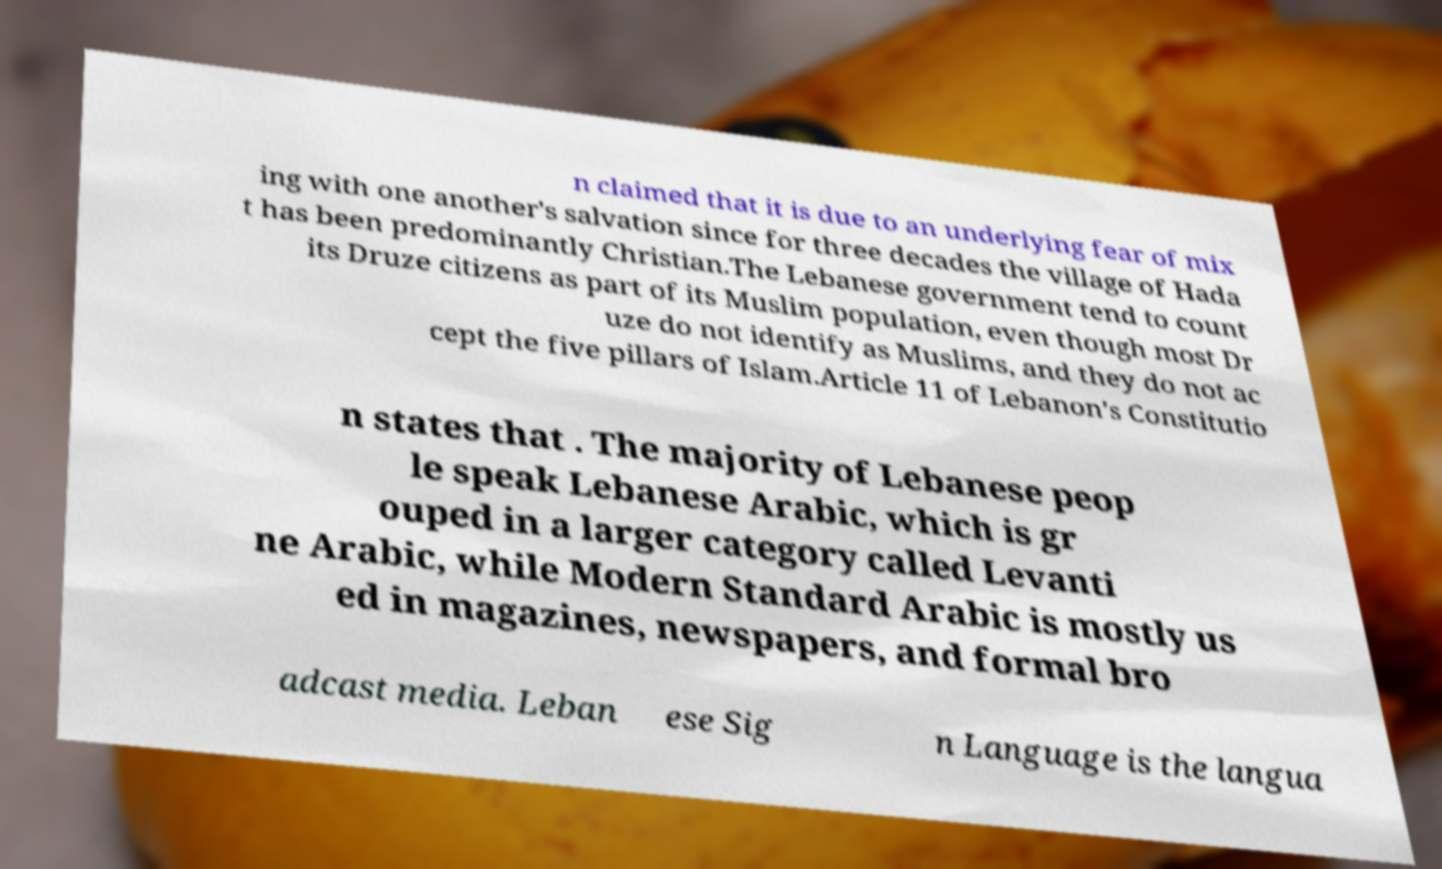Could you extract and type out the text from this image? n claimed that it is due to an underlying fear of mix ing with one another's salvation since for three decades the village of Hada t has been predominantly Christian.The Lebanese government tend to count its Druze citizens as part of its Muslim population, even though most Dr uze do not identify as Muslims, and they do not ac cept the five pillars of Islam.Article 11 of Lebanon's Constitutio n states that . The majority of Lebanese peop le speak Lebanese Arabic, which is gr ouped in a larger category called Levanti ne Arabic, while Modern Standard Arabic is mostly us ed in magazines, newspapers, and formal bro adcast media. Leban ese Sig n Language is the langua 